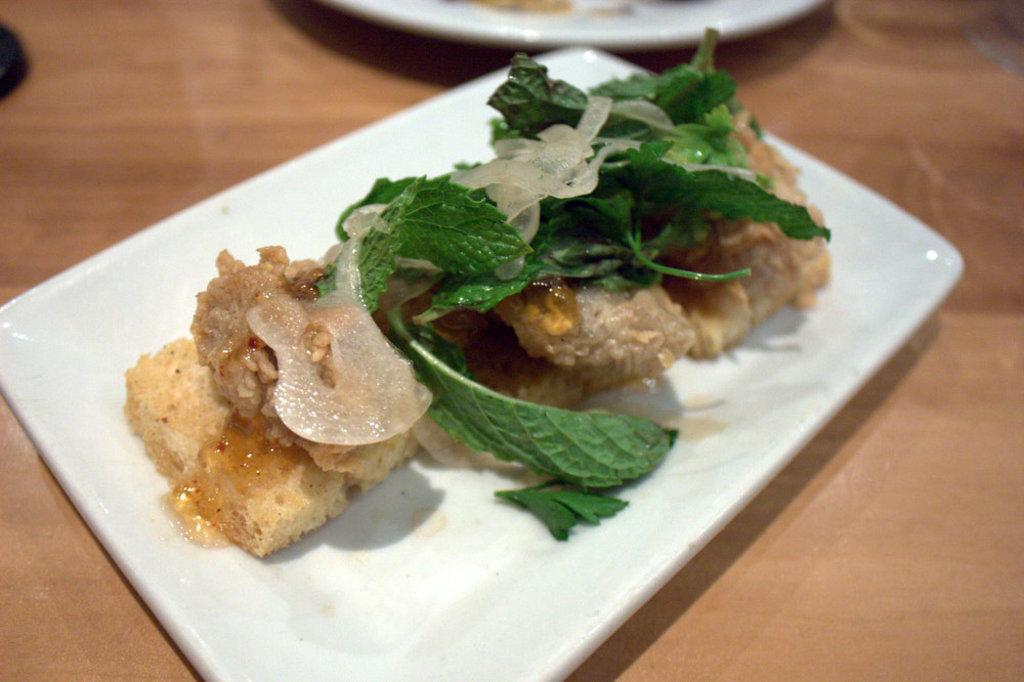What is the main subject of the image? The main subject of the image is a food item in a plate. Where is the plate with the food item located? The plate with the food item is on a table. Are there any other plates visible in the image? Yes, there is another plate beside the plate with the food item. What type of headwear is the person wearing in the image? There is no person present in the image, only a plate with a food item and another plate. 